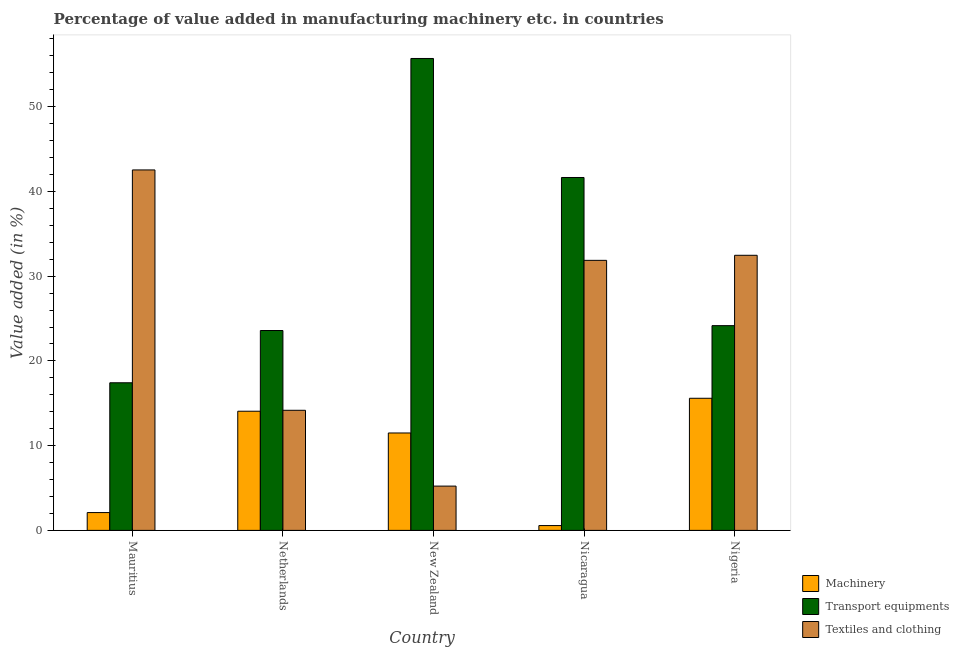How many different coloured bars are there?
Keep it short and to the point. 3. How many groups of bars are there?
Offer a very short reply. 5. Are the number of bars per tick equal to the number of legend labels?
Keep it short and to the point. Yes. What is the label of the 4th group of bars from the left?
Ensure brevity in your answer.  Nicaragua. What is the value added in manufacturing transport equipments in Nicaragua?
Your answer should be very brief. 41.64. Across all countries, what is the maximum value added in manufacturing transport equipments?
Provide a short and direct response. 55.69. Across all countries, what is the minimum value added in manufacturing textile and clothing?
Offer a terse response. 5.23. In which country was the value added in manufacturing transport equipments maximum?
Give a very brief answer. New Zealand. In which country was the value added in manufacturing machinery minimum?
Give a very brief answer. Nicaragua. What is the total value added in manufacturing machinery in the graph?
Keep it short and to the point. 43.82. What is the difference between the value added in manufacturing textile and clothing in Mauritius and that in New Zealand?
Give a very brief answer. 37.31. What is the difference between the value added in manufacturing transport equipments in New Zealand and the value added in manufacturing machinery in Netherlands?
Keep it short and to the point. 41.63. What is the average value added in manufacturing machinery per country?
Your answer should be compact. 8.76. What is the difference between the value added in manufacturing transport equipments and value added in manufacturing textile and clothing in Mauritius?
Your response must be concise. -25.12. In how many countries, is the value added in manufacturing textile and clothing greater than 46 %?
Your answer should be very brief. 0. What is the ratio of the value added in manufacturing transport equipments in New Zealand to that in Nigeria?
Your answer should be compact. 2.3. Is the value added in manufacturing transport equipments in Mauritius less than that in Nicaragua?
Make the answer very short. Yes. What is the difference between the highest and the second highest value added in manufacturing machinery?
Provide a succinct answer. 1.53. What is the difference between the highest and the lowest value added in manufacturing transport equipments?
Offer a terse response. 38.27. In how many countries, is the value added in manufacturing machinery greater than the average value added in manufacturing machinery taken over all countries?
Your response must be concise. 3. Is the sum of the value added in manufacturing textile and clothing in Mauritius and Netherlands greater than the maximum value added in manufacturing machinery across all countries?
Offer a terse response. Yes. What does the 2nd bar from the left in New Zealand represents?
Give a very brief answer. Transport equipments. What does the 2nd bar from the right in Netherlands represents?
Keep it short and to the point. Transport equipments. Is it the case that in every country, the sum of the value added in manufacturing machinery and value added in manufacturing transport equipments is greater than the value added in manufacturing textile and clothing?
Offer a terse response. No. How many bars are there?
Offer a very short reply. 15. Are all the bars in the graph horizontal?
Make the answer very short. No. What is the difference between two consecutive major ticks on the Y-axis?
Provide a succinct answer. 10. Are the values on the major ticks of Y-axis written in scientific E-notation?
Provide a succinct answer. No. Does the graph contain grids?
Make the answer very short. No. How are the legend labels stacked?
Ensure brevity in your answer.  Vertical. What is the title of the graph?
Provide a short and direct response. Percentage of value added in manufacturing machinery etc. in countries. What is the label or title of the Y-axis?
Provide a succinct answer. Value added (in %). What is the Value added (in %) in Machinery in Mauritius?
Make the answer very short. 2.1. What is the Value added (in %) in Transport equipments in Mauritius?
Make the answer very short. 17.42. What is the Value added (in %) in Textiles and clothing in Mauritius?
Your response must be concise. 42.54. What is the Value added (in %) of Machinery in Netherlands?
Ensure brevity in your answer.  14.06. What is the Value added (in %) of Transport equipments in Netherlands?
Keep it short and to the point. 23.59. What is the Value added (in %) of Textiles and clothing in Netherlands?
Offer a terse response. 14.17. What is the Value added (in %) of Machinery in New Zealand?
Your answer should be compact. 11.49. What is the Value added (in %) of Transport equipments in New Zealand?
Provide a short and direct response. 55.69. What is the Value added (in %) of Textiles and clothing in New Zealand?
Keep it short and to the point. 5.23. What is the Value added (in %) in Machinery in Nicaragua?
Provide a short and direct response. 0.57. What is the Value added (in %) in Transport equipments in Nicaragua?
Keep it short and to the point. 41.64. What is the Value added (in %) in Textiles and clothing in Nicaragua?
Give a very brief answer. 31.87. What is the Value added (in %) in Machinery in Nigeria?
Your answer should be compact. 15.59. What is the Value added (in %) of Transport equipments in Nigeria?
Give a very brief answer. 24.16. What is the Value added (in %) of Textiles and clothing in Nigeria?
Your answer should be compact. 32.46. Across all countries, what is the maximum Value added (in %) in Machinery?
Give a very brief answer. 15.59. Across all countries, what is the maximum Value added (in %) of Transport equipments?
Your answer should be very brief. 55.69. Across all countries, what is the maximum Value added (in %) in Textiles and clothing?
Ensure brevity in your answer.  42.54. Across all countries, what is the minimum Value added (in %) in Machinery?
Keep it short and to the point. 0.57. Across all countries, what is the minimum Value added (in %) of Transport equipments?
Provide a short and direct response. 17.42. Across all countries, what is the minimum Value added (in %) in Textiles and clothing?
Make the answer very short. 5.23. What is the total Value added (in %) of Machinery in the graph?
Keep it short and to the point. 43.82. What is the total Value added (in %) of Transport equipments in the graph?
Offer a terse response. 162.5. What is the total Value added (in %) of Textiles and clothing in the graph?
Offer a very short reply. 126.27. What is the difference between the Value added (in %) of Machinery in Mauritius and that in Netherlands?
Make the answer very short. -11.96. What is the difference between the Value added (in %) in Transport equipments in Mauritius and that in Netherlands?
Ensure brevity in your answer.  -6.17. What is the difference between the Value added (in %) of Textiles and clothing in Mauritius and that in Netherlands?
Offer a terse response. 28.36. What is the difference between the Value added (in %) of Machinery in Mauritius and that in New Zealand?
Offer a very short reply. -9.39. What is the difference between the Value added (in %) in Transport equipments in Mauritius and that in New Zealand?
Make the answer very short. -38.27. What is the difference between the Value added (in %) in Textiles and clothing in Mauritius and that in New Zealand?
Keep it short and to the point. 37.31. What is the difference between the Value added (in %) in Machinery in Mauritius and that in Nicaragua?
Give a very brief answer. 1.53. What is the difference between the Value added (in %) in Transport equipments in Mauritius and that in Nicaragua?
Provide a short and direct response. -24.22. What is the difference between the Value added (in %) in Textiles and clothing in Mauritius and that in Nicaragua?
Your answer should be very brief. 10.67. What is the difference between the Value added (in %) in Machinery in Mauritius and that in Nigeria?
Your answer should be compact. -13.49. What is the difference between the Value added (in %) in Transport equipments in Mauritius and that in Nigeria?
Your response must be concise. -6.74. What is the difference between the Value added (in %) of Textiles and clothing in Mauritius and that in Nigeria?
Your answer should be very brief. 10.07. What is the difference between the Value added (in %) in Machinery in Netherlands and that in New Zealand?
Provide a short and direct response. 2.57. What is the difference between the Value added (in %) of Transport equipments in Netherlands and that in New Zealand?
Your answer should be very brief. -32.1. What is the difference between the Value added (in %) of Textiles and clothing in Netherlands and that in New Zealand?
Make the answer very short. 8.95. What is the difference between the Value added (in %) in Machinery in Netherlands and that in Nicaragua?
Your answer should be compact. 13.49. What is the difference between the Value added (in %) in Transport equipments in Netherlands and that in Nicaragua?
Your answer should be very brief. -18.06. What is the difference between the Value added (in %) of Textiles and clothing in Netherlands and that in Nicaragua?
Keep it short and to the point. -17.69. What is the difference between the Value added (in %) in Machinery in Netherlands and that in Nigeria?
Provide a short and direct response. -1.53. What is the difference between the Value added (in %) of Transport equipments in Netherlands and that in Nigeria?
Provide a short and direct response. -0.57. What is the difference between the Value added (in %) of Textiles and clothing in Netherlands and that in Nigeria?
Provide a short and direct response. -18.29. What is the difference between the Value added (in %) in Machinery in New Zealand and that in Nicaragua?
Provide a succinct answer. 10.93. What is the difference between the Value added (in %) of Transport equipments in New Zealand and that in Nicaragua?
Ensure brevity in your answer.  14.05. What is the difference between the Value added (in %) in Textiles and clothing in New Zealand and that in Nicaragua?
Provide a succinct answer. -26.64. What is the difference between the Value added (in %) of Machinery in New Zealand and that in Nigeria?
Give a very brief answer. -4.1. What is the difference between the Value added (in %) of Transport equipments in New Zealand and that in Nigeria?
Ensure brevity in your answer.  31.53. What is the difference between the Value added (in %) in Textiles and clothing in New Zealand and that in Nigeria?
Offer a terse response. -27.24. What is the difference between the Value added (in %) of Machinery in Nicaragua and that in Nigeria?
Keep it short and to the point. -15.02. What is the difference between the Value added (in %) in Transport equipments in Nicaragua and that in Nigeria?
Provide a succinct answer. 17.48. What is the difference between the Value added (in %) in Textiles and clothing in Nicaragua and that in Nigeria?
Your answer should be compact. -0.6. What is the difference between the Value added (in %) of Machinery in Mauritius and the Value added (in %) of Transport equipments in Netherlands?
Your answer should be very brief. -21.49. What is the difference between the Value added (in %) in Machinery in Mauritius and the Value added (in %) in Textiles and clothing in Netherlands?
Your answer should be very brief. -12.07. What is the difference between the Value added (in %) of Transport equipments in Mauritius and the Value added (in %) of Textiles and clothing in Netherlands?
Your response must be concise. 3.25. What is the difference between the Value added (in %) of Machinery in Mauritius and the Value added (in %) of Transport equipments in New Zealand?
Ensure brevity in your answer.  -53.59. What is the difference between the Value added (in %) in Machinery in Mauritius and the Value added (in %) in Textiles and clothing in New Zealand?
Give a very brief answer. -3.12. What is the difference between the Value added (in %) in Transport equipments in Mauritius and the Value added (in %) in Textiles and clothing in New Zealand?
Provide a short and direct response. 12.19. What is the difference between the Value added (in %) of Machinery in Mauritius and the Value added (in %) of Transport equipments in Nicaragua?
Offer a very short reply. -39.54. What is the difference between the Value added (in %) in Machinery in Mauritius and the Value added (in %) in Textiles and clothing in Nicaragua?
Ensure brevity in your answer.  -29.76. What is the difference between the Value added (in %) of Transport equipments in Mauritius and the Value added (in %) of Textiles and clothing in Nicaragua?
Ensure brevity in your answer.  -14.45. What is the difference between the Value added (in %) in Machinery in Mauritius and the Value added (in %) in Transport equipments in Nigeria?
Ensure brevity in your answer.  -22.06. What is the difference between the Value added (in %) of Machinery in Mauritius and the Value added (in %) of Textiles and clothing in Nigeria?
Provide a short and direct response. -30.36. What is the difference between the Value added (in %) in Transport equipments in Mauritius and the Value added (in %) in Textiles and clothing in Nigeria?
Ensure brevity in your answer.  -15.04. What is the difference between the Value added (in %) in Machinery in Netherlands and the Value added (in %) in Transport equipments in New Zealand?
Provide a short and direct response. -41.63. What is the difference between the Value added (in %) in Machinery in Netherlands and the Value added (in %) in Textiles and clothing in New Zealand?
Ensure brevity in your answer.  8.84. What is the difference between the Value added (in %) of Transport equipments in Netherlands and the Value added (in %) of Textiles and clothing in New Zealand?
Give a very brief answer. 18.36. What is the difference between the Value added (in %) of Machinery in Netherlands and the Value added (in %) of Transport equipments in Nicaragua?
Your answer should be compact. -27.58. What is the difference between the Value added (in %) of Machinery in Netherlands and the Value added (in %) of Textiles and clothing in Nicaragua?
Offer a very short reply. -17.8. What is the difference between the Value added (in %) of Transport equipments in Netherlands and the Value added (in %) of Textiles and clothing in Nicaragua?
Provide a short and direct response. -8.28. What is the difference between the Value added (in %) of Machinery in Netherlands and the Value added (in %) of Transport equipments in Nigeria?
Provide a succinct answer. -10.1. What is the difference between the Value added (in %) of Machinery in Netherlands and the Value added (in %) of Textiles and clothing in Nigeria?
Your answer should be compact. -18.4. What is the difference between the Value added (in %) of Transport equipments in Netherlands and the Value added (in %) of Textiles and clothing in Nigeria?
Your response must be concise. -8.88. What is the difference between the Value added (in %) of Machinery in New Zealand and the Value added (in %) of Transport equipments in Nicaragua?
Keep it short and to the point. -30.15. What is the difference between the Value added (in %) in Machinery in New Zealand and the Value added (in %) in Textiles and clothing in Nicaragua?
Your response must be concise. -20.37. What is the difference between the Value added (in %) of Transport equipments in New Zealand and the Value added (in %) of Textiles and clothing in Nicaragua?
Offer a terse response. 23.82. What is the difference between the Value added (in %) of Machinery in New Zealand and the Value added (in %) of Transport equipments in Nigeria?
Offer a very short reply. -12.67. What is the difference between the Value added (in %) in Machinery in New Zealand and the Value added (in %) in Textiles and clothing in Nigeria?
Give a very brief answer. -20.97. What is the difference between the Value added (in %) of Transport equipments in New Zealand and the Value added (in %) of Textiles and clothing in Nigeria?
Your answer should be compact. 23.23. What is the difference between the Value added (in %) in Machinery in Nicaragua and the Value added (in %) in Transport equipments in Nigeria?
Your response must be concise. -23.59. What is the difference between the Value added (in %) of Machinery in Nicaragua and the Value added (in %) of Textiles and clothing in Nigeria?
Provide a succinct answer. -31.9. What is the difference between the Value added (in %) in Transport equipments in Nicaragua and the Value added (in %) in Textiles and clothing in Nigeria?
Provide a succinct answer. 9.18. What is the average Value added (in %) in Machinery per country?
Make the answer very short. 8.76. What is the average Value added (in %) in Transport equipments per country?
Provide a succinct answer. 32.5. What is the average Value added (in %) of Textiles and clothing per country?
Provide a succinct answer. 25.25. What is the difference between the Value added (in %) in Machinery and Value added (in %) in Transport equipments in Mauritius?
Your response must be concise. -15.32. What is the difference between the Value added (in %) in Machinery and Value added (in %) in Textiles and clothing in Mauritius?
Keep it short and to the point. -40.43. What is the difference between the Value added (in %) in Transport equipments and Value added (in %) in Textiles and clothing in Mauritius?
Your answer should be very brief. -25.12. What is the difference between the Value added (in %) in Machinery and Value added (in %) in Transport equipments in Netherlands?
Your answer should be very brief. -9.53. What is the difference between the Value added (in %) of Machinery and Value added (in %) of Textiles and clothing in Netherlands?
Provide a short and direct response. -0.11. What is the difference between the Value added (in %) of Transport equipments and Value added (in %) of Textiles and clothing in Netherlands?
Your answer should be very brief. 9.42. What is the difference between the Value added (in %) in Machinery and Value added (in %) in Transport equipments in New Zealand?
Your response must be concise. -44.2. What is the difference between the Value added (in %) of Machinery and Value added (in %) of Textiles and clothing in New Zealand?
Give a very brief answer. 6.27. What is the difference between the Value added (in %) in Transport equipments and Value added (in %) in Textiles and clothing in New Zealand?
Your answer should be compact. 50.46. What is the difference between the Value added (in %) in Machinery and Value added (in %) in Transport equipments in Nicaragua?
Provide a succinct answer. -41.08. What is the difference between the Value added (in %) of Machinery and Value added (in %) of Textiles and clothing in Nicaragua?
Keep it short and to the point. -31.3. What is the difference between the Value added (in %) of Transport equipments and Value added (in %) of Textiles and clothing in Nicaragua?
Ensure brevity in your answer.  9.78. What is the difference between the Value added (in %) of Machinery and Value added (in %) of Transport equipments in Nigeria?
Provide a short and direct response. -8.57. What is the difference between the Value added (in %) in Machinery and Value added (in %) in Textiles and clothing in Nigeria?
Keep it short and to the point. -16.87. What is the difference between the Value added (in %) in Transport equipments and Value added (in %) in Textiles and clothing in Nigeria?
Give a very brief answer. -8.3. What is the ratio of the Value added (in %) of Machinery in Mauritius to that in Netherlands?
Your answer should be very brief. 0.15. What is the ratio of the Value added (in %) of Transport equipments in Mauritius to that in Netherlands?
Give a very brief answer. 0.74. What is the ratio of the Value added (in %) of Textiles and clothing in Mauritius to that in Netherlands?
Your answer should be compact. 3. What is the ratio of the Value added (in %) in Machinery in Mauritius to that in New Zealand?
Offer a terse response. 0.18. What is the ratio of the Value added (in %) of Transport equipments in Mauritius to that in New Zealand?
Provide a short and direct response. 0.31. What is the ratio of the Value added (in %) of Textiles and clothing in Mauritius to that in New Zealand?
Ensure brevity in your answer.  8.14. What is the ratio of the Value added (in %) of Machinery in Mauritius to that in Nicaragua?
Offer a terse response. 3.7. What is the ratio of the Value added (in %) in Transport equipments in Mauritius to that in Nicaragua?
Make the answer very short. 0.42. What is the ratio of the Value added (in %) of Textiles and clothing in Mauritius to that in Nicaragua?
Ensure brevity in your answer.  1.33. What is the ratio of the Value added (in %) in Machinery in Mauritius to that in Nigeria?
Provide a short and direct response. 0.13. What is the ratio of the Value added (in %) in Transport equipments in Mauritius to that in Nigeria?
Your answer should be very brief. 0.72. What is the ratio of the Value added (in %) of Textiles and clothing in Mauritius to that in Nigeria?
Your answer should be very brief. 1.31. What is the ratio of the Value added (in %) of Machinery in Netherlands to that in New Zealand?
Keep it short and to the point. 1.22. What is the ratio of the Value added (in %) in Transport equipments in Netherlands to that in New Zealand?
Keep it short and to the point. 0.42. What is the ratio of the Value added (in %) in Textiles and clothing in Netherlands to that in New Zealand?
Give a very brief answer. 2.71. What is the ratio of the Value added (in %) of Machinery in Netherlands to that in Nicaragua?
Keep it short and to the point. 24.76. What is the ratio of the Value added (in %) of Transport equipments in Netherlands to that in Nicaragua?
Provide a succinct answer. 0.57. What is the ratio of the Value added (in %) of Textiles and clothing in Netherlands to that in Nicaragua?
Offer a terse response. 0.44. What is the ratio of the Value added (in %) of Machinery in Netherlands to that in Nigeria?
Offer a very short reply. 0.9. What is the ratio of the Value added (in %) in Transport equipments in Netherlands to that in Nigeria?
Offer a very short reply. 0.98. What is the ratio of the Value added (in %) of Textiles and clothing in Netherlands to that in Nigeria?
Give a very brief answer. 0.44. What is the ratio of the Value added (in %) of Machinery in New Zealand to that in Nicaragua?
Provide a short and direct response. 20.24. What is the ratio of the Value added (in %) of Transport equipments in New Zealand to that in Nicaragua?
Your answer should be very brief. 1.34. What is the ratio of the Value added (in %) of Textiles and clothing in New Zealand to that in Nicaragua?
Offer a terse response. 0.16. What is the ratio of the Value added (in %) of Machinery in New Zealand to that in Nigeria?
Your answer should be compact. 0.74. What is the ratio of the Value added (in %) in Transport equipments in New Zealand to that in Nigeria?
Ensure brevity in your answer.  2.3. What is the ratio of the Value added (in %) in Textiles and clothing in New Zealand to that in Nigeria?
Keep it short and to the point. 0.16. What is the ratio of the Value added (in %) of Machinery in Nicaragua to that in Nigeria?
Make the answer very short. 0.04. What is the ratio of the Value added (in %) of Transport equipments in Nicaragua to that in Nigeria?
Keep it short and to the point. 1.72. What is the ratio of the Value added (in %) in Textiles and clothing in Nicaragua to that in Nigeria?
Offer a terse response. 0.98. What is the difference between the highest and the second highest Value added (in %) of Machinery?
Offer a terse response. 1.53. What is the difference between the highest and the second highest Value added (in %) of Transport equipments?
Your response must be concise. 14.05. What is the difference between the highest and the second highest Value added (in %) of Textiles and clothing?
Provide a succinct answer. 10.07. What is the difference between the highest and the lowest Value added (in %) of Machinery?
Your answer should be very brief. 15.02. What is the difference between the highest and the lowest Value added (in %) of Transport equipments?
Provide a succinct answer. 38.27. What is the difference between the highest and the lowest Value added (in %) of Textiles and clothing?
Offer a terse response. 37.31. 